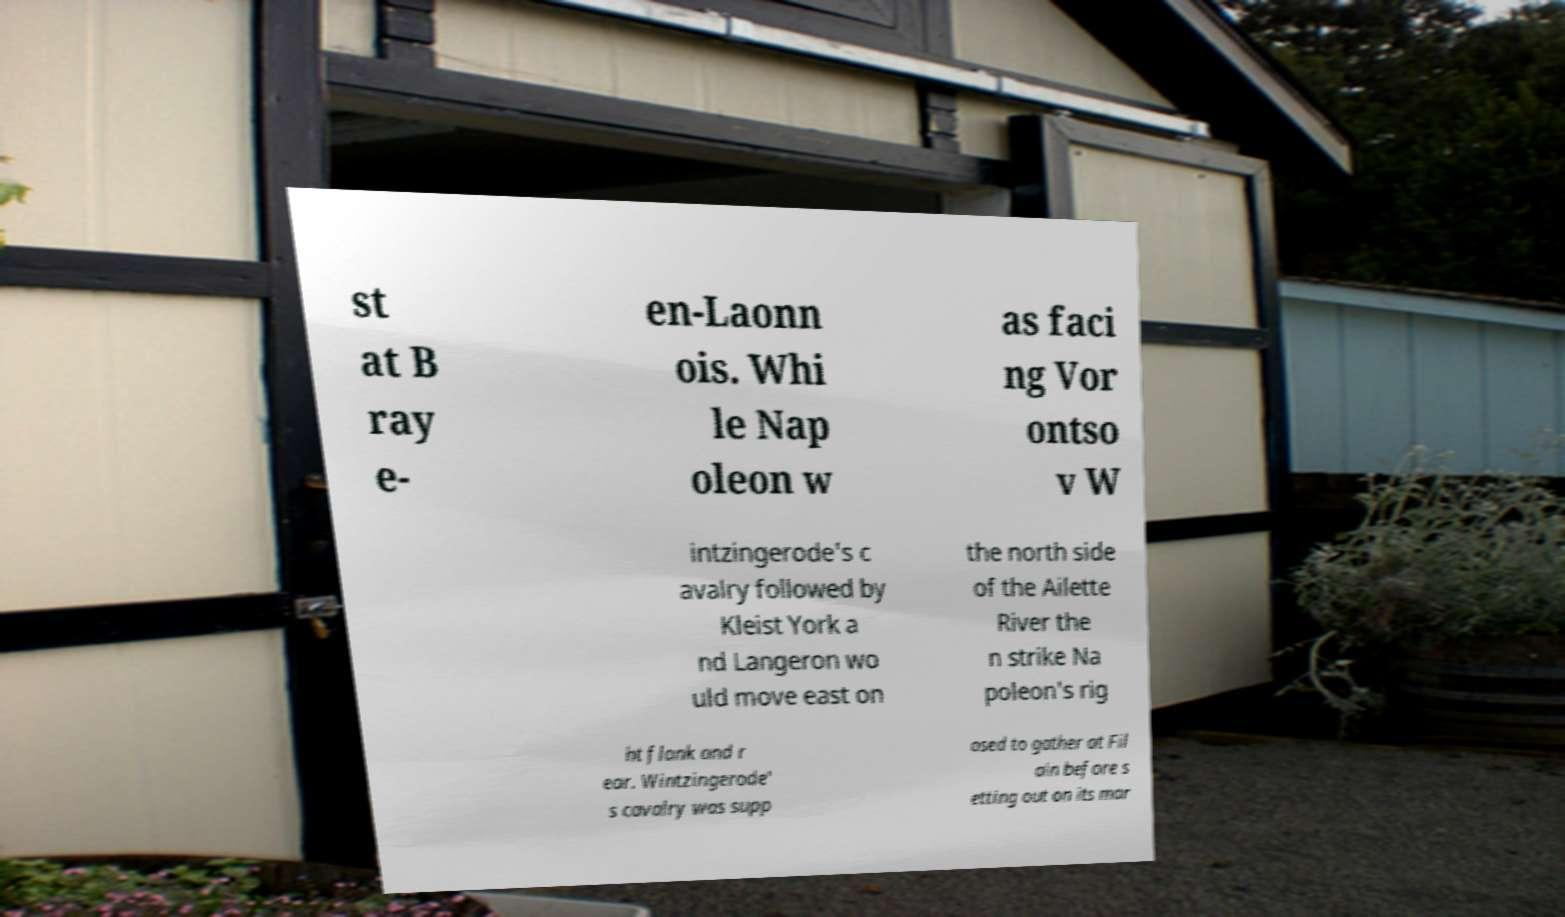For documentation purposes, I need the text within this image transcribed. Could you provide that? st at B ray e- en-Laonn ois. Whi le Nap oleon w as faci ng Vor ontso v W intzingerode's c avalry followed by Kleist York a nd Langeron wo uld move east on the north side of the Ailette River the n strike Na poleon's rig ht flank and r ear. Wintzingerode' s cavalry was supp osed to gather at Fil ain before s etting out on its mar 